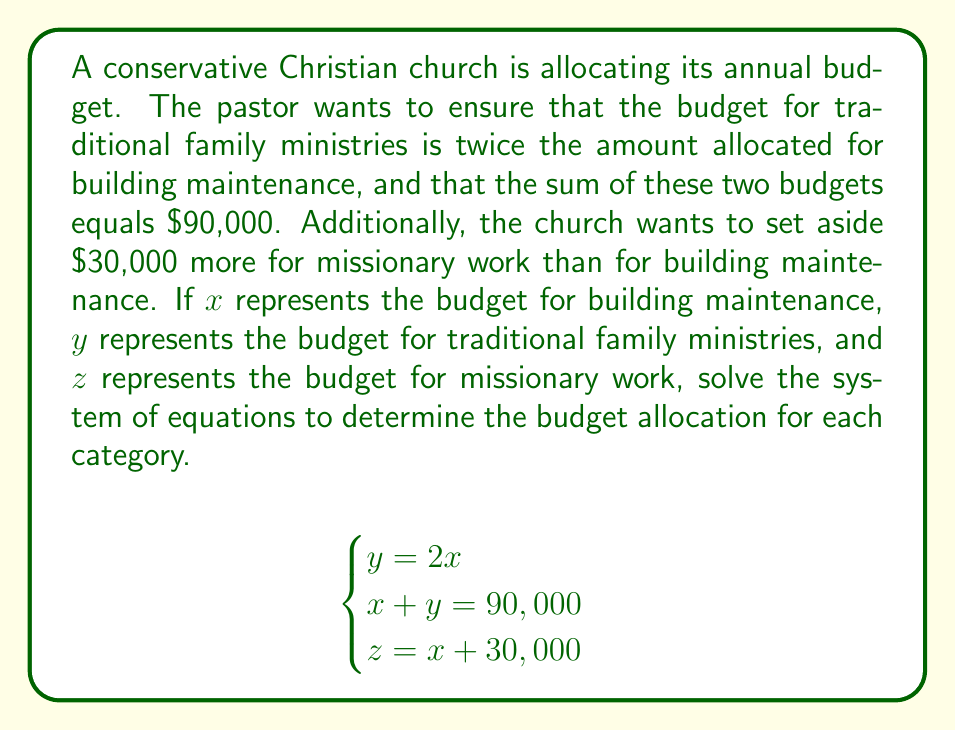What is the answer to this math problem? Let's solve this system of equations step by step:

1) From the first equation, we know that $y = 2x$

2) Substitute this into the second equation:
   $x + 2x = 90,000$
   $3x = 90,000$

3) Solve for x:
   $x = 90,000 \div 3 = 30,000$

4) Now that we know x, we can find y:
   $y = 2x = 2(30,000) = 60,000$

5) To find z, we use the third equation:
   $z = x + 30,000 = 30,000 + 30,000 = 60,000$

Therefore, the budget allocations are:
Building maintenance (x): $30,000
Traditional family ministries (y): $60,000
Missionary work (z): $60,000
Answer: Building maintenance: $30,000
Traditional family ministries: $60,000
Missionary work: $60,000 